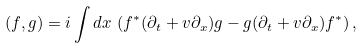Convert formula to latex. <formula><loc_0><loc_0><loc_500><loc_500>( f , g ) = i \int d x \, \left ( f ^ { * } ( \partial _ { t } + v \partial _ { x } ) g - g ( \partial _ { t } + v \partial _ { x } ) f ^ { * } \right ) ,</formula> 